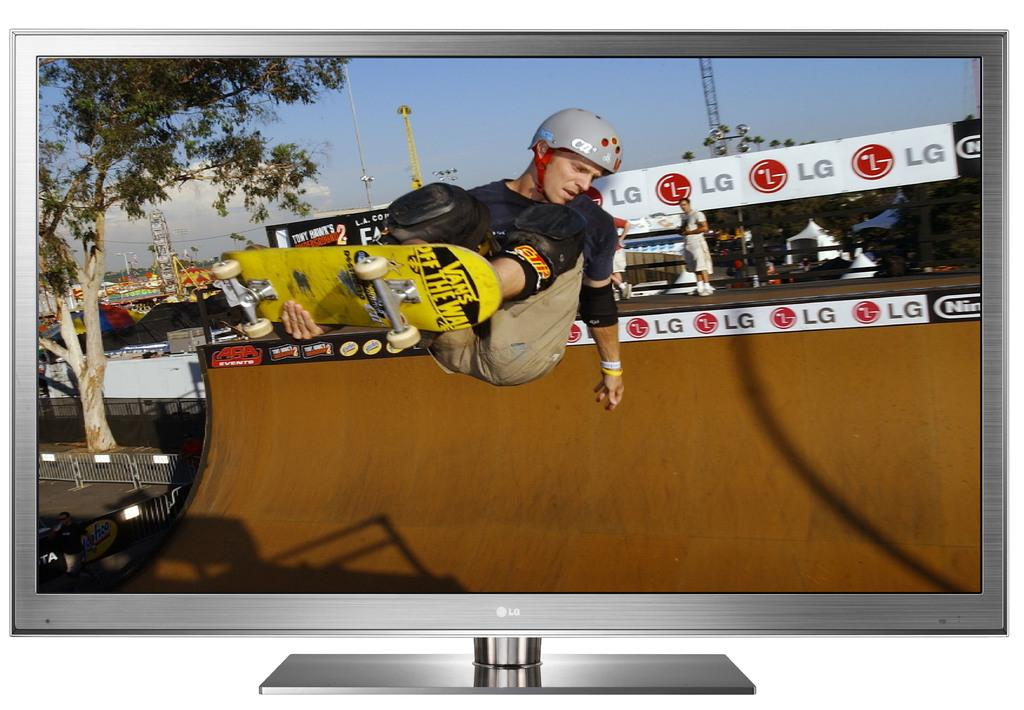<image>
Present a compact description of the photo's key features. a skater riding on a ramp with an LG ad near 